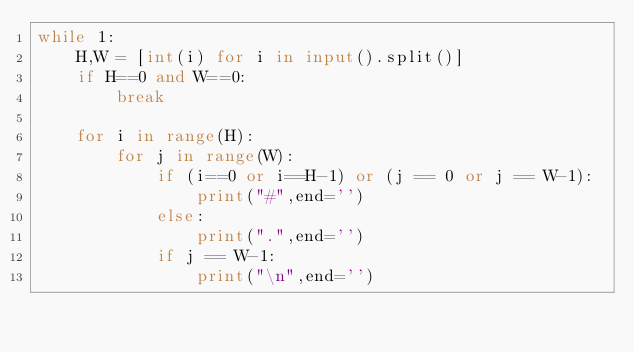<code> <loc_0><loc_0><loc_500><loc_500><_Python_>while 1:
	H,W = [int(i) for i in input().split()]
	if H==0 and W==0:
		break

	for i in range(H):
		for j in range(W):
			if (i==0 or i==H-1) or (j == 0 or j == W-1):
				print("#",end='')
			else:
				print(".",end='')
			if j == W-1:
				print("\n",end='')</code> 